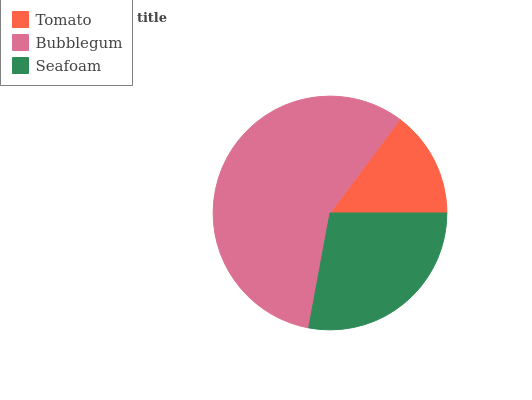Is Tomato the minimum?
Answer yes or no. Yes. Is Bubblegum the maximum?
Answer yes or no. Yes. Is Seafoam the minimum?
Answer yes or no. No. Is Seafoam the maximum?
Answer yes or no. No. Is Bubblegum greater than Seafoam?
Answer yes or no. Yes. Is Seafoam less than Bubblegum?
Answer yes or no. Yes. Is Seafoam greater than Bubblegum?
Answer yes or no. No. Is Bubblegum less than Seafoam?
Answer yes or no. No. Is Seafoam the high median?
Answer yes or no. Yes. Is Seafoam the low median?
Answer yes or no. Yes. Is Bubblegum the high median?
Answer yes or no. No. Is Tomato the low median?
Answer yes or no. No. 